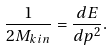<formula> <loc_0><loc_0><loc_500><loc_500>\frac { 1 } { 2 M _ { k i n } } = \frac { d E } { d p ^ { 2 } } .</formula> 